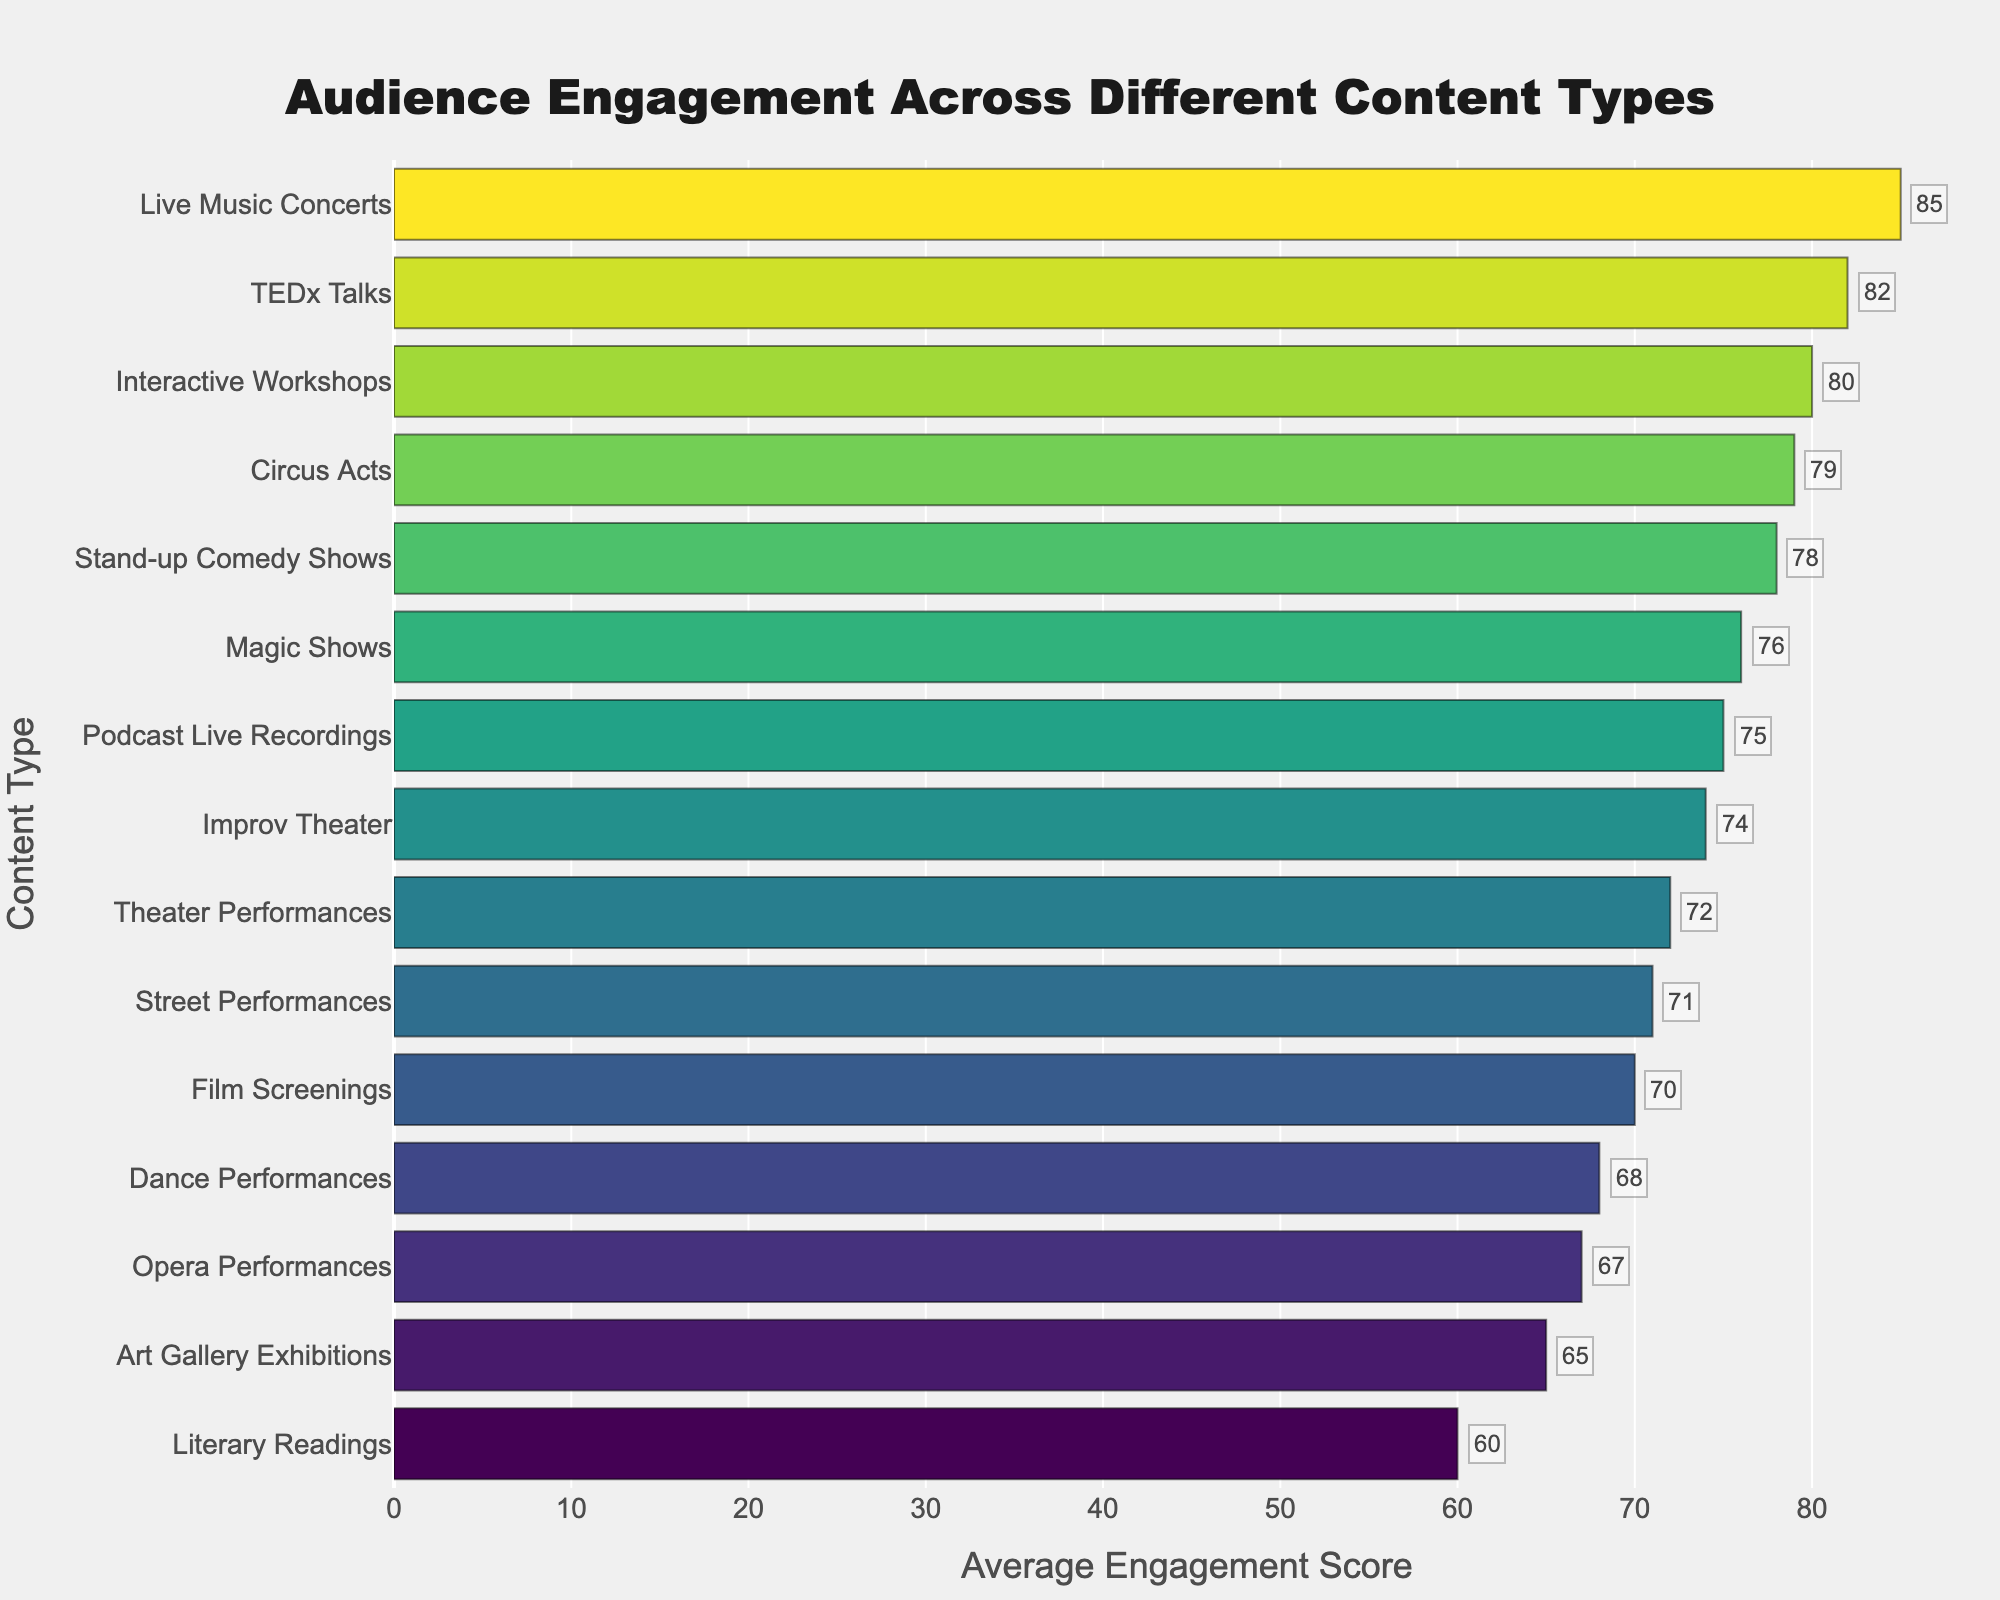Which content type has the highest average engagement score? The figure shows a bar chart with different content types on the Y-axis and their average engagement scores on the X-axis. The content type with the longest bar will have the highest engagement score.
Answer: Live Music Concerts Which content type has the lowest average engagement score? The content type with the shortest bar will have the lowest engagement score.
Answer: Literary Readings What's the difference in average engagement score between Live Music Concerts and Literary Readings? The average engagement score for Live Music Concerts is 85 and for Literary Readings is 60. The difference is calculated by subtracting the smaller score from the larger one: 85 - 60.
Answer: 25 Which content type has a higher engagement score: TEDx Talks or Street Performances? By comparing the lengths of the bars for TEDx Talks and Street Performances, it's clear that TEDx Talks has a longer bar, indicating a higher engagement score.
Answer: TEDx Talks How many content types have an average engagement score above 75? By counting the number of bars that extend beyond the 75 mark on the X-axis, we can determine how many content types have an engagement score above 75.
Answer: 6 What's the average engagement score for the three content types with the highest scores? The three content types with the highest scores are Live Music Concerts (85), TEDx Talks (82), and Interactive Workshops (80). The average is calculated as (85 + 82 + 80) / 3.
Answer: 82.33 Which content type has a higher engagement score: Improv Theater or Magic Shows? By comparing the lengths of the bars for Improv Theater and Magic Shows, the longer bar corresponds to the content type with the higher engagement score.
Answer: Magic Shows Is the average engagement score of Dance Performances higher or lower than the average engagement score of Opera Performances? By comparing the lengths of the bars for Dance Performances (68) and Opera Performances (67), Dance Performances has a longer bar and thus a higher score.
Answer: Higher What is the sum of the average engagement scores for Art Gallery Exhibitions, Film Screenings, and Circus Acts? The average engagement scores are 65 for Art Gallery Exhibitions, 70 for Film Screenings, and 79 for Circus Acts. The sum is calculated as 65 + 70 + 79.
Answer: 214 Which has a greater difference in average engagement scores: between Stand-up Comedy Shows and Art Gallery Exhibitions or between Podcast Live Recordings and TEDx Talks? First, calculate the differences:
Stand-up Comedy Shows (78) - Art Gallery Exhibitions (65) = 13
Podcast Live Recordings (75) - TEDx Talks (82) = 7
Compare the two differences to determine the greater one.
Answer: Stand-up Comedy Shows and Art Gallery Exhibitions 